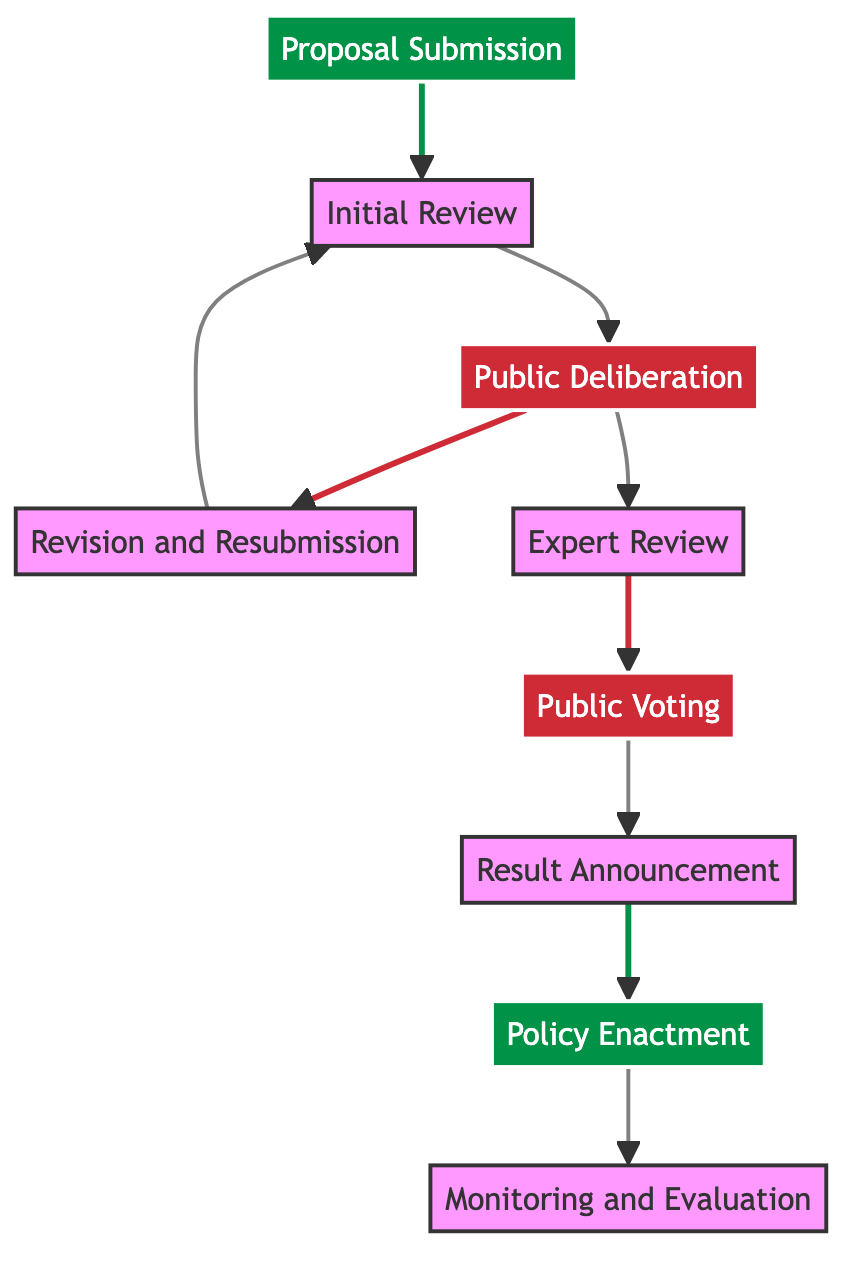What is the first stage in the policy proposal journey? The first stage is indicated by the node labeled "Proposal Submission," which is the initial action taken by citizens or advocacy groups.
Answer: Proposal Submission How many total stages are there in the flowchart? By counting all the unique nodes displayed in the diagram, there are nine distinct stages from submission to evaluation.
Answer: 9 Which stage follows 'Public Deliberation'? The diagram shows that 'Public Deliberation' directly connects to 'Revision and Resubmission' and 'Expert Review,' but 'Revision and Resubmission' immediately follows.
Answer: Revision and Resubmission What do citizens do during the 'Public Voting' stage? In this stage, citizens participate by casting their votes, as indicated in the description of the 'Public Voting' node.
Answer: Cast their votes How does 'Proposal Submission' link to 'Policy Enactment'? The flow can be traced from 'Proposal Submission' through several intermediate stages, including review, deliberation, voting, and result announcement, leading to 'Policy Enactment.'
Answer: Multiple stages What is the purpose of the 'Expert Review' stage? The description of the 'Expert Review' node states that a panel of experts evaluates the proposal for feasibility, legal consistency, and potential impact, marking its importance in the process.
Answer: Evaluate the proposal In how many stages is public engagement emphasized? Public engagement is emphasized in 'Public Deliberation' and 'Public Voting,' indicating there are two stages focused on citizen involvement in the policy process.
Answer: 2 What happens after 'Result Announcement'? The next action depicted in the flowchart after 'Result Announcement' is 'Policy Enactment,' showing the progression towards implementing the approved proposal.
Answer: Policy Enactment What is the last stage in the policy proposal journey? The final stage is clearly labeled as 'Monitoring and Evaluation,' which involves assessing the impact of enacted policies.
Answer: Monitoring and Evaluation 